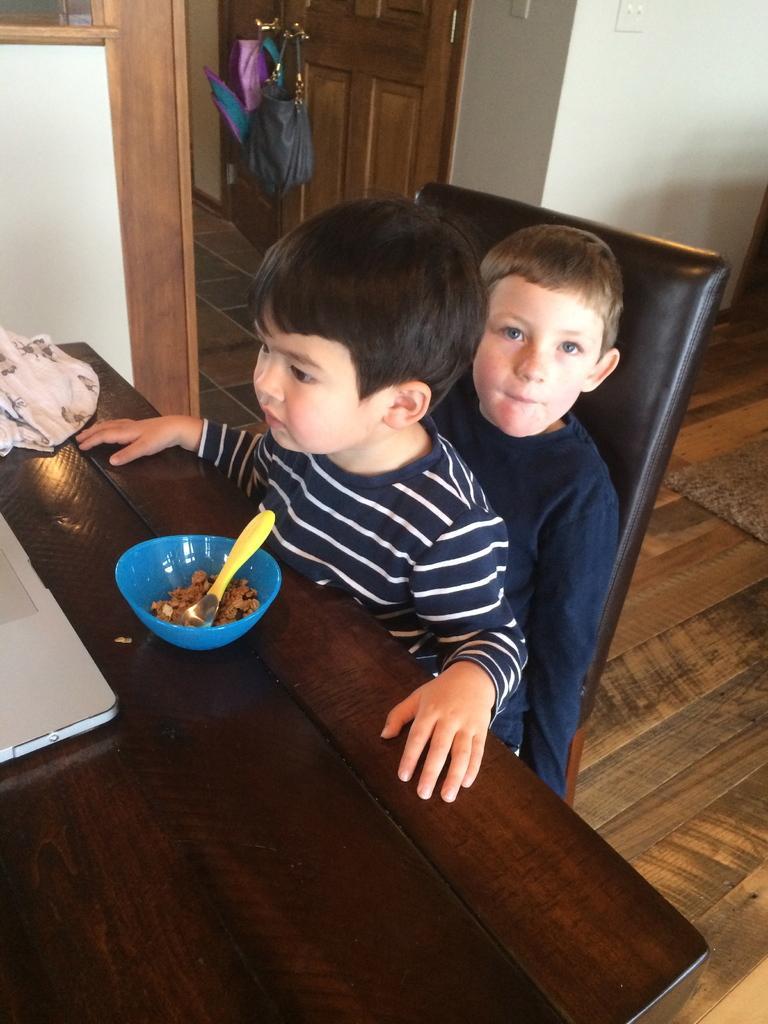In one or two sentences, can you explain what this image depicts? This 2 kids are sitting on chair. On this table there is a cloth, bowl and spoon. Bags over door. 